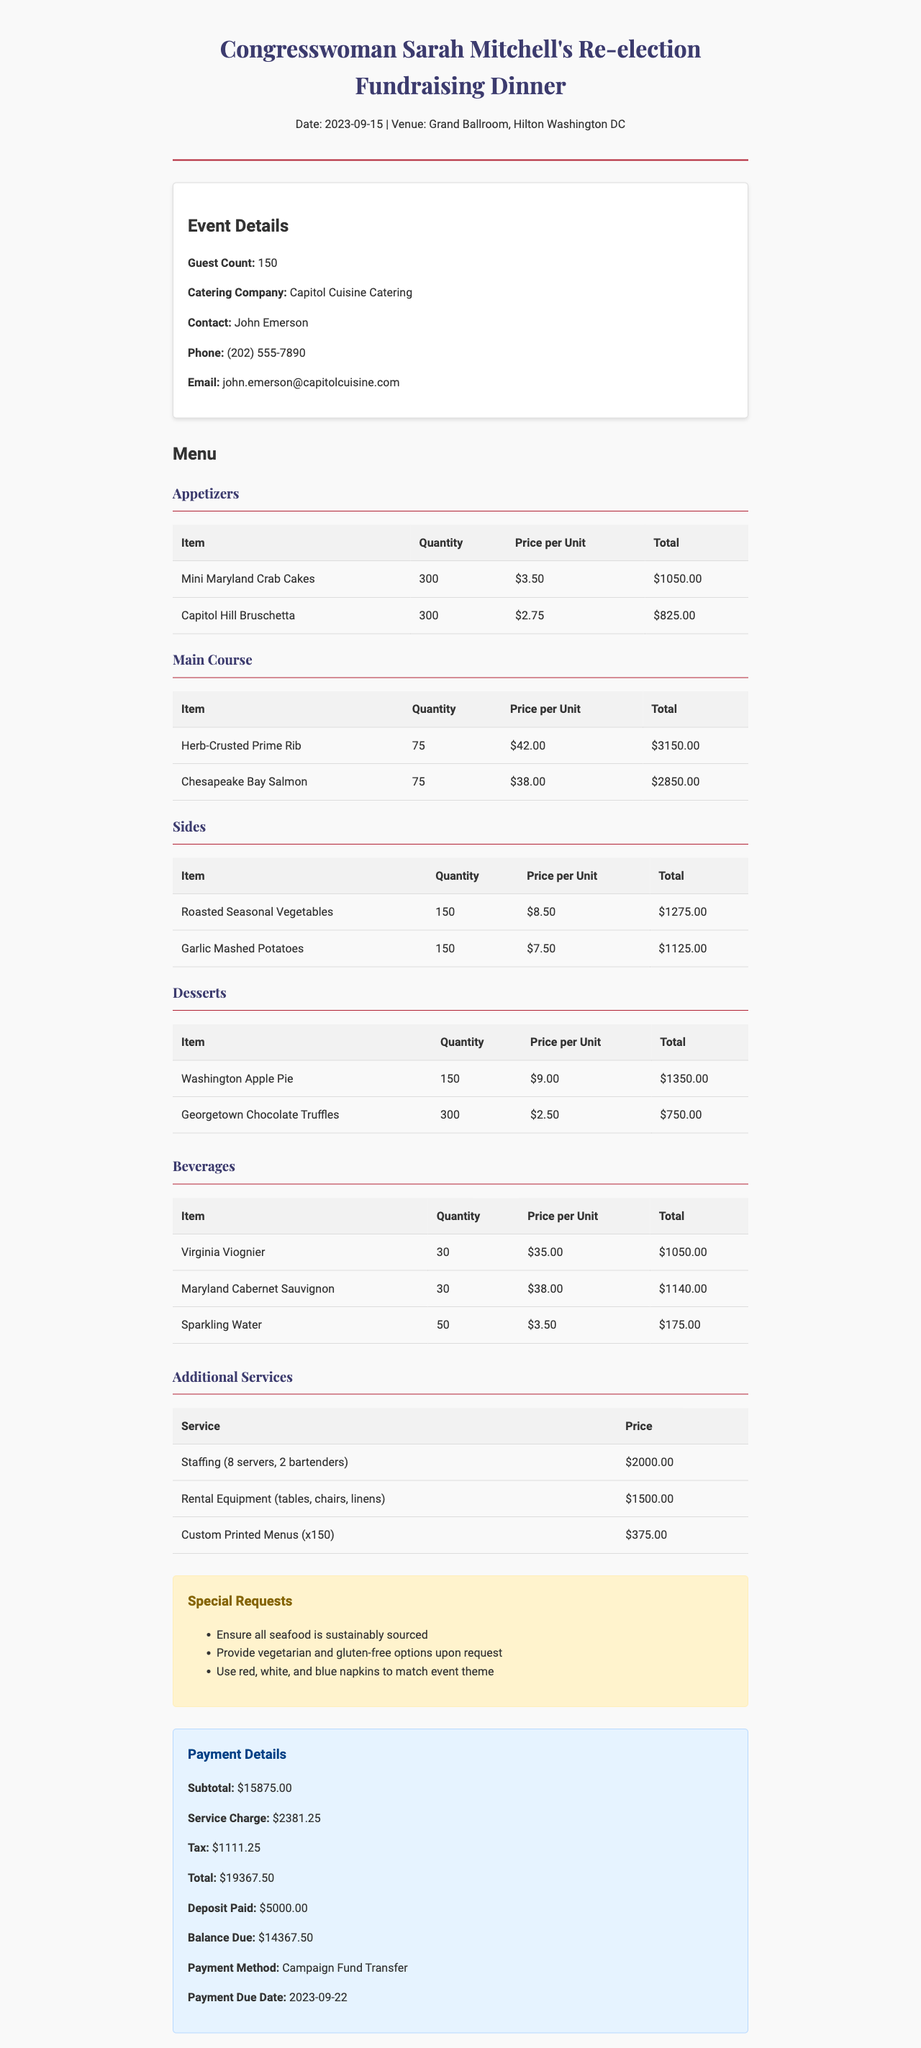What is the guest count? The guest count is directly stated in the event details section of the document.
Answer: 150 What is the name of the catering company? The catering company name is provided in the catering company section of the document.
Answer: Capitol Cuisine Catering How many Mini Maryland Crab Cakes were ordered? The quantity of Mini Maryland Crab Cakes is specified in the menu items section.
Answer: 300 What is the total amount due? The total amount due can be found in the payment details section of the document.
Answer: 19367.50 What special request was made regarding seafood? One of the special requests is outlined clearly in the special requests section of the document.
Answer: Ensure all seafood is sustainably sourced How much was paid as a deposit? The deposit amount is listed under the payment details section in the document.
Answer: 5000.00 What type of wine is included in the beverage menu? The types of wine listed can be found in the beverages section of the document.
Answer: Virginia Viognier, Maryland Cabernet Sauvignon How many servers and bartenders were provided? The staffing details are included in the additional services section of the document, indicating the number of servers and bartenders.
Answer: 8 servers, 2 bartenders What is the price per bottle of Virginia Viognier? The price per bottle of Virginia Viognier is mentioned in the beverages section of the document.
Answer: 35.00 